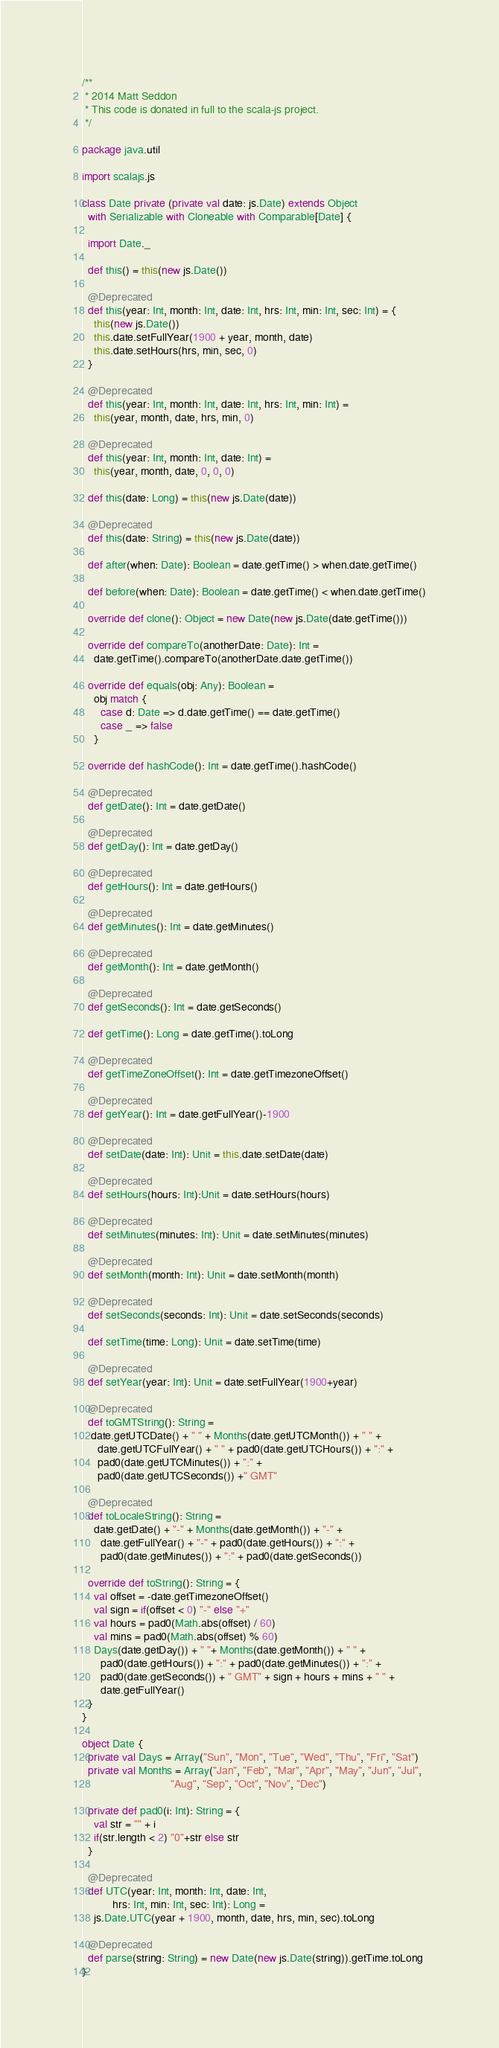Convert code to text. <code><loc_0><loc_0><loc_500><loc_500><_Scala_>/**
 * 2014 Matt Seddon
 * This code is donated in full to the scala-js project.
 */

package java.util

import scalajs.js

class Date private (private val date: js.Date) extends Object
  with Serializable with Cloneable with Comparable[Date] {

  import Date._

  def this() = this(new js.Date())

  @Deprecated
  def this(year: Int, month: Int, date: Int, hrs: Int, min: Int, sec: Int) = {
    this(new js.Date())
    this.date.setFullYear(1900 + year, month, date)
    this.date.setHours(hrs, min, sec, 0)
  }

  @Deprecated
  def this(year: Int, month: Int, date: Int, hrs: Int, min: Int) =
    this(year, month, date, hrs, min, 0)

  @Deprecated
  def this(year: Int, month: Int, date: Int) =
    this(year, month, date, 0, 0, 0)

  def this(date: Long) = this(new js.Date(date))

  @Deprecated
  def this(date: String) = this(new js.Date(date))

  def after(when: Date): Boolean = date.getTime() > when.date.getTime()

  def before(when: Date): Boolean = date.getTime() < when.date.getTime()

  override def clone(): Object = new Date(new js.Date(date.getTime()))

  override def compareTo(anotherDate: Date): Int =
    date.getTime().compareTo(anotherDate.date.getTime())

  override def equals(obj: Any): Boolean =
    obj match {
      case d: Date => d.date.getTime() == date.getTime()
      case _ => false
    }

  override def hashCode(): Int = date.getTime().hashCode()

  @Deprecated
  def getDate(): Int = date.getDate()

  @Deprecated
  def getDay(): Int = date.getDay()

  @Deprecated
  def getHours(): Int = date.getHours()

  @Deprecated
  def getMinutes(): Int = date.getMinutes()

  @Deprecated
  def getMonth(): Int = date.getMonth()

  @Deprecated
  def getSeconds(): Int = date.getSeconds()

  def getTime(): Long = date.getTime().toLong

  @Deprecated
  def getTimeZoneOffset(): Int = date.getTimezoneOffset()

  @Deprecated
  def getYear(): Int = date.getFullYear()-1900

  @Deprecated
  def setDate(date: Int): Unit = this.date.setDate(date)

  @Deprecated
  def setHours(hours: Int):Unit = date.setHours(hours)

  @Deprecated
  def setMinutes(minutes: Int): Unit = date.setMinutes(minutes)

  @Deprecated
  def setMonth(month: Int): Unit = date.setMonth(month)

  @Deprecated
  def setSeconds(seconds: Int): Unit = date.setSeconds(seconds)

  def setTime(time: Long): Unit = date.setTime(time)

  @Deprecated
  def setYear(year: Int): Unit = date.setFullYear(1900+year)

  @Deprecated
  def toGMTString(): String =
   date.getUTCDate() + " " + Months(date.getUTCMonth()) + " " +
     date.getUTCFullYear() + " " + pad0(date.getUTCHours()) + ":" +
     pad0(date.getUTCMinutes()) + ":" +
     pad0(date.getUTCSeconds()) +" GMT"

  @Deprecated
  def toLocaleString(): String =
    date.getDate() + "-" + Months(date.getMonth()) + "-" +
      date.getFullYear() + "-" + pad0(date.getHours()) + ":" +
      pad0(date.getMinutes()) + ":" + pad0(date.getSeconds())

  override def toString(): String = {
    val offset = -date.getTimezoneOffset()
    val sign = if(offset < 0) "-" else "+"
    val hours = pad0(Math.abs(offset) / 60)
    val mins = pad0(Math.abs(offset) % 60)
    Days(date.getDay()) + " "+ Months(date.getMonth()) + " " +
      pad0(date.getHours()) + ":" + pad0(date.getMinutes()) + ":" +
      pad0(date.getSeconds()) + " GMT" + sign + hours + mins + " " +
      date.getFullYear()
  }
}

object Date {
  private val Days = Array("Sun", "Mon", "Tue", "Wed", "Thu", "Fri", "Sat")
  private val Months = Array("Jan", "Feb", "Mar", "Apr", "May", "Jun", "Jul",
                             "Aug", "Sep", "Oct", "Nov", "Dec")

  private def pad0(i: Int): String = {
    val str = "" + i
    if(str.length < 2) "0"+str else str
  }

  @Deprecated
  def UTC(year: Int, month: Int, date: Int,
          hrs: Int, min: Int, sec: Int): Long =
    js.Date.UTC(year + 1900, month, date, hrs, min, sec).toLong

  @Deprecated
  def parse(string: String) = new Date(new js.Date(string)).getTime.toLong
}
</code> 